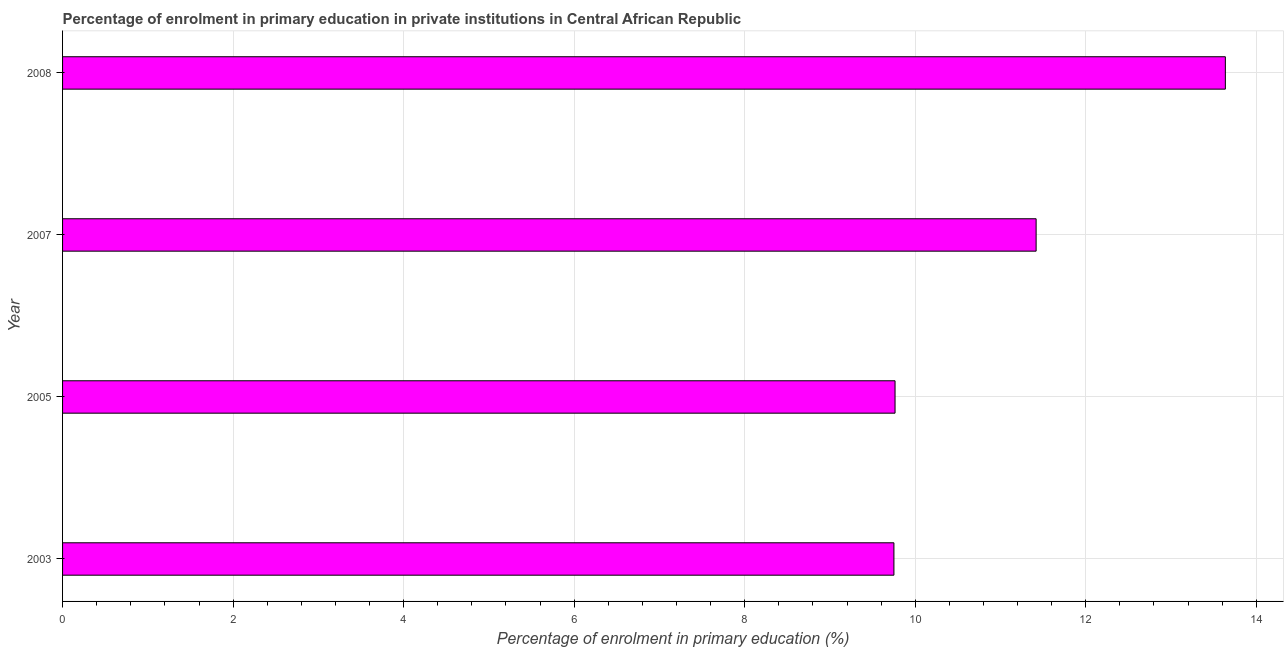Does the graph contain grids?
Your response must be concise. Yes. What is the title of the graph?
Give a very brief answer. Percentage of enrolment in primary education in private institutions in Central African Republic. What is the label or title of the X-axis?
Offer a very short reply. Percentage of enrolment in primary education (%). What is the enrolment percentage in primary education in 2003?
Offer a very short reply. 9.75. Across all years, what is the maximum enrolment percentage in primary education?
Ensure brevity in your answer.  13.64. Across all years, what is the minimum enrolment percentage in primary education?
Offer a very short reply. 9.75. What is the sum of the enrolment percentage in primary education?
Offer a terse response. 44.57. What is the difference between the enrolment percentage in primary education in 2005 and 2007?
Offer a very short reply. -1.65. What is the average enrolment percentage in primary education per year?
Ensure brevity in your answer.  11.14. What is the median enrolment percentage in primary education?
Your response must be concise. 10.59. In how many years, is the enrolment percentage in primary education greater than 7.6 %?
Offer a very short reply. 4. Do a majority of the years between 2008 and 2007 (inclusive) have enrolment percentage in primary education greater than 12.8 %?
Ensure brevity in your answer.  No. What is the ratio of the enrolment percentage in primary education in 2005 to that in 2008?
Your answer should be compact. 0.72. Is the difference between the enrolment percentage in primary education in 2003 and 2005 greater than the difference between any two years?
Provide a short and direct response. No. What is the difference between the highest and the second highest enrolment percentage in primary education?
Ensure brevity in your answer.  2.22. Is the sum of the enrolment percentage in primary education in 2005 and 2008 greater than the maximum enrolment percentage in primary education across all years?
Give a very brief answer. Yes. What is the difference between the highest and the lowest enrolment percentage in primary education?
Provide a succinct answer. 3.89. In how many years, is the enrolment percentage in primary education greater than the average enrolment percentage in primary education taken over all years?
Provide a succinct answer. 2. Are all the bars in the graph horizontal?
Provide a short and direct response. Yes. How many years are there in the graph?
Provide a short and direct response. 4. What is the difference between two consecutive major ticks on the X-axis?
Keep it short and to the point. 2. Are the values on the major ticks of X-axis written in scientific E-notation?
Ensure brevity in your answer.  No. What is the Percentage of enrolment in primary education (%) of 2003?
Provide a succinct answer. 9.75. What is the Percentage of enrolment in primary education (%) in 2005?
Offer a terse response. 9.76. What is the Percentage of enrolment in primary education (%) of 2007?
Your answer should be very brief. 11.42. What is the Percentage of enrolment in primary education (%) in 2008?
Give a very brief answer. 13.64. What is the difference between the Percentage of enrolment in primary education (%) in 2003 and 2005?
Offer a very short reply. -0.01. What is the difference between the Percentage of enrolment in primary education (%) in 2003 and 2007?
Keep it short and to the point. -1.67. What is the difference between the Percentage of enrolment in primary education (%) in 2003 and 2008?
Your answer should be very brief. -3.89. What is the difference between the Percentage of enrolment in primary education (%) in 2005 and 2007?
Make the answer very short. -1.65. What is the difference between the Percentage of enrolment in primary education (%) in 2005 and 2008?
Give a very brief answer. -3.87. What is the difference between the Percentage of enrolment in primary education (%) in 2007 and 2008?
Make the answer very short. -2.22. What is the ratio of the Percentage of enrolment in primary education (%) in 2003 to that in 2005?
Provide a succinct answer. 1. What is the ratio of the Percentage of enrolment in primary education (%) in 2003 to that in 2007?
Offer a terse response. 0.85. What is the ratio of the Percentage of enrolment in primary education (%) in 2003 to that in 2008?
Your response must be concise. 0.71. What is the ratio of the Percentage of enrolment in primary education (%) in 2005 to that in 2007?
Offer a terse response. 0.85. What is the ratio of the Percentage of enrolment in primary education (%) in 2005 to that in 2008?
Offer a very short reply. 0.72. What is the ratio of the Percentage of enrolment in primary education (%) in 2007 to that in 2008?
Provide a short and direct response. 0.84. 